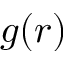<formula> <loc_0><loc_0><loc_500><loc_500>g ( r )</formula> 